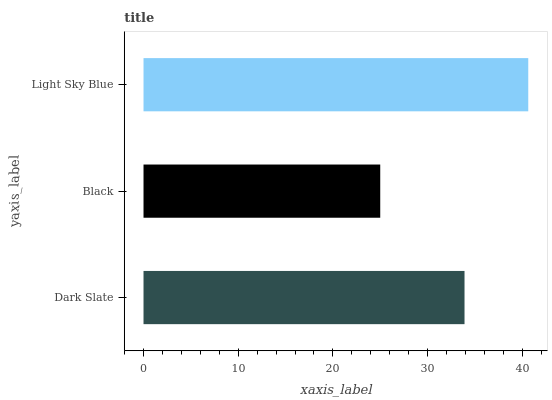Is Black the minimum?
Answer yes or no. Yes. Is Light Sky Blue the maximum?
Answer yes or no. Yes. Is Light Sky Blue the minimum?
Answer yes or no. No. Is Black the maximum?
Answer yes or no. No. Is Light Sky Blue greater than Black?
Answer yes or no. Yes. Is Black less than Light Sky Blue?
Answer yes or no. Yes. Is Black greater than Light Sky Blue?
Answer yes or no. No. Is Light Sky Blue less than Black?
Answer yes or no. No. Is Dark Slate the high median?
Answer yes or no. Yes. Is Dark Slate the low median?
Answer yes or no. Yes. Is Black the high median?
Answer yes or no. No. Is Light Sky Blue the low median?
Answer yes or no. No. 